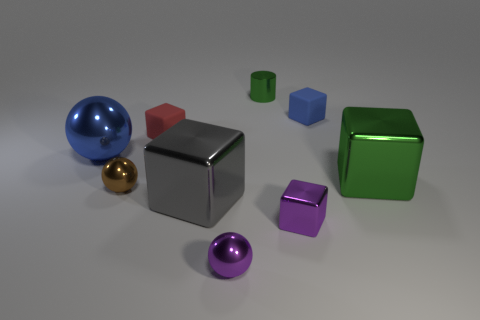What number of shiny things are there? 7 